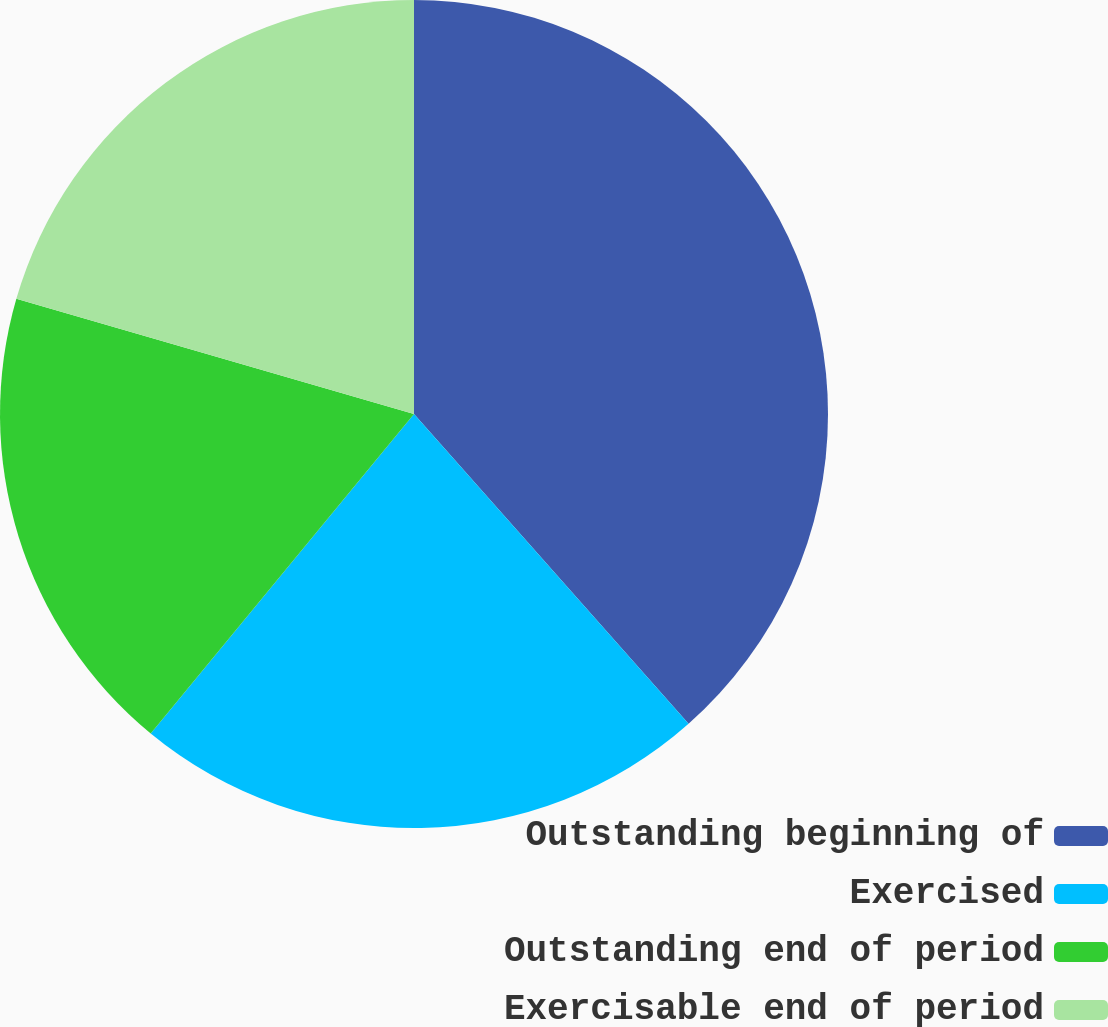Convert chart. <chart><loc_0><loc_0><loc_500><loc_500><pie_chart><fcel>Outstanding beginning of<fcel>Exercised<fcel>Outstanding end of period<fcel>Exercisable end of period<nl><fcel>38.46%<fcel>22.51%<fcel>18.52%<fcel>20.51%<nl></chart> 